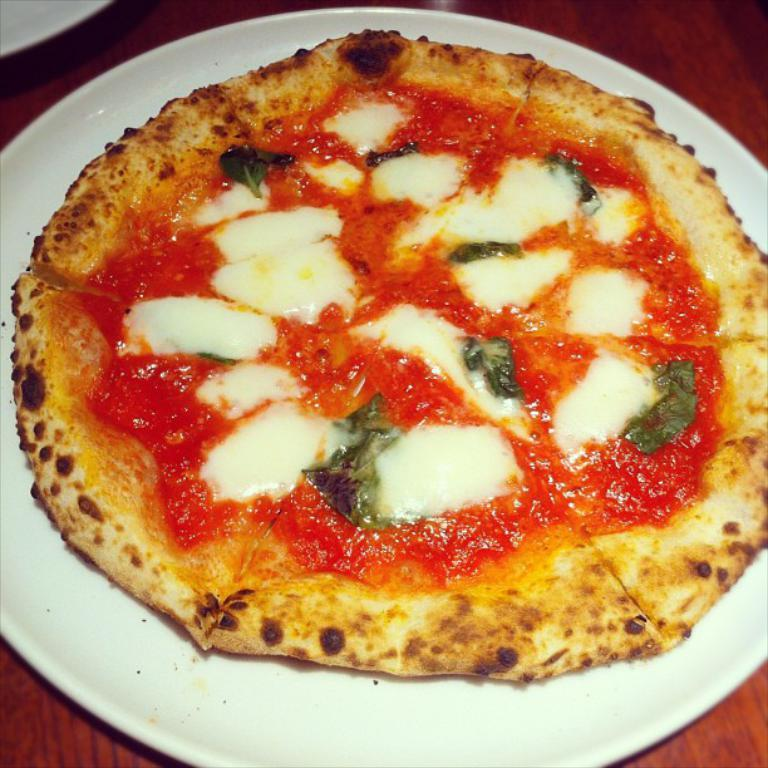What color is the plate in the image? The plate in the image is white colored. What is the plate placed on? The plate is on a brown colored table. What food item is on the plate? There is a pizza on the plate. What colors can be seen on the pizza? The pizza has cream, red, brown, and green colors. Can you see any girls playing in the garden near the water in the image? There is no mention of girls, a garden, or water in the image; it only features a white plate with a pizza on a brown table. 